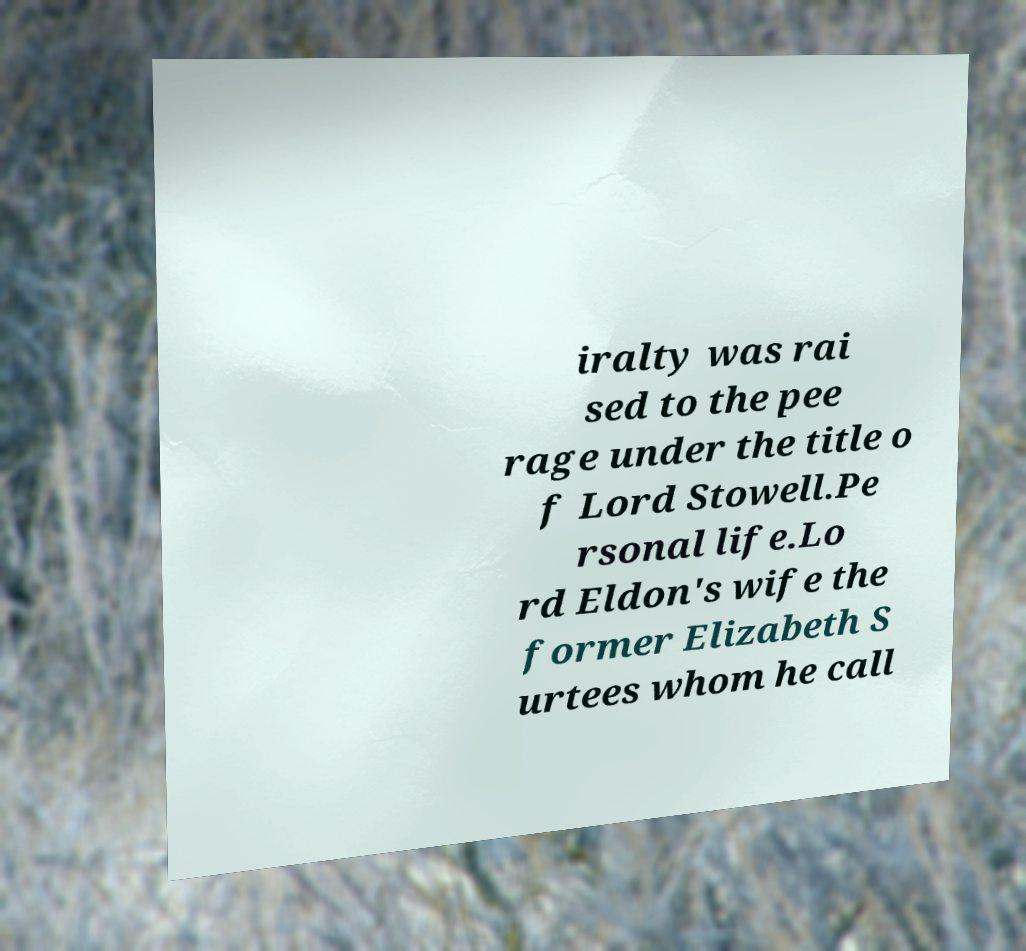Please identify and transcribe the text found in this image. iralty was rai sed to the pee rage under the title o f Lord Stowell.Pe rsonal life.Lo rd Eldon's wife the former Elizabeth S urtees whom he call 